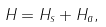<formula> <loc_0><loc_0><loc_500><loc_500>H = H _ { s } + H _ { a } ,</formula> 